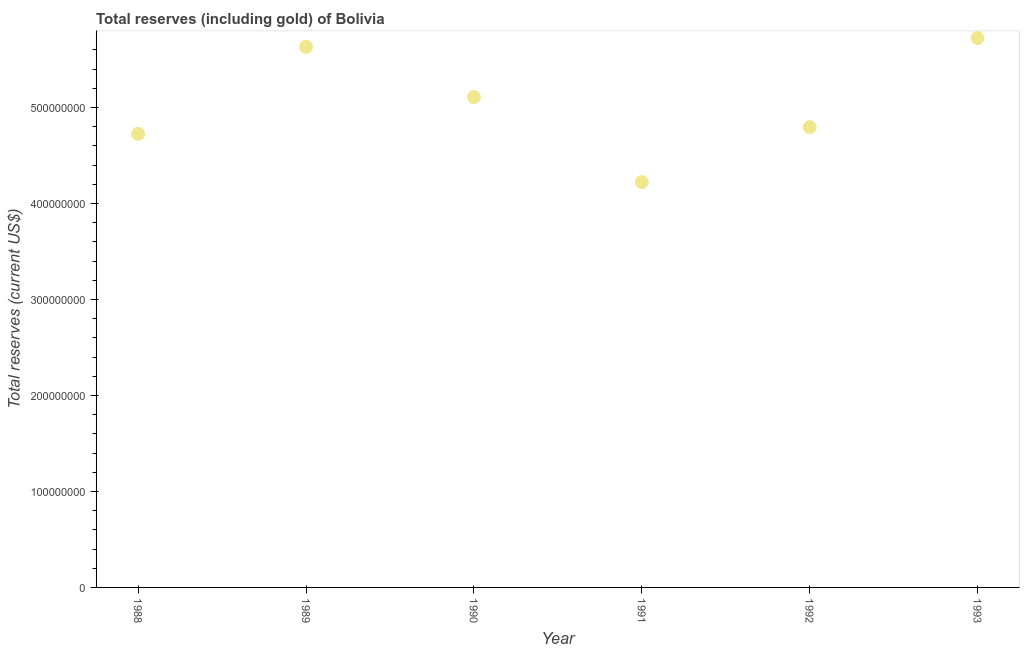What is the total reserves (including gold) in 1988?
Make the answer very short. 4.73e+08. Across all years, what is the maximum total reserves (including gold)?
Provide a succinct answer. 5.72e+08. Across all years, what is the minimum total reserves (including gold)?
Give a very brief answer. 4.22e+08. In which year was the total reserves (including gold) maximum?
Your answer should be compact. 1993. In which year was the total reserves (including gold) minimum?
Ensure brevity in your answer.  1991. What is the sum of the total reserves (including gold)?
Offer a very short reply. 3.02e+09. What is the difference between the total reserves (including gold) in 1990 and 1992?
Offer a terse response. 3.14e+07. What is the average total reserves (including gold) per year?
Give a very brief answer. 5.04e+08. What is the median total reserves (including gold)?
Provide a short and direct response. 4.95e+08. What is the ratio of the total reserves (including gold) in 1989 to that in 1991?
Your answer should be very brief. 1.33. What is the difference between the highest and the second highest total reserves (including gold)?
Your answer should be compact. 9.09e+06. What is the difference between the highest and the lowest total reserves (including gold)?
Your response must be concise. 1.50e+08. In how many years, is the total reserves (including gold) greater than the average total reserves (including gold) taken over all years?
Offer a very short reply. 3. Does the total reserves (including gold) monotonically increase over the years?
Offer a very short reply. No. How many years are there in the graph?
Offer a very short reply. 6. Are the values on the major ticks of Y-axis written in scientific E-notation?
Offer a very short reply. No. Does the graph contain any zero values?
Ensure brevity in your answer.  No. What is the title of the graph?
Give a very brief answer. Total reserves (including gold) of Bolivia. What is the label or title of the X-axis?
Make the answer very short. Year. What is the label or title of the Y-axis?
Your answer should be very brief. Total reserves (current US$). What is the Total reserves (current US$) in 1988?
Offer a very short reply. 4.73e+08. What is the Total reserves (current US$) in 1989?
Your answer should be very brief. 5.63e+08. What is the Total reserves (current US$) in 1990?
Your response must be concise. 5.11e+08. What is the Total reserves (current US$) in 1991?
Offer a very short reply. 4.22e+08. What is the Total reserves (current US$) in 1992?
Provide a succinct answer. 4.80e+08. What is the Total reserves (current US$) in 1993?
Your response must be concise. 5.72e+08. What is the difference between the Total reserves (current US$) in 1988 and 1989?
Ensure brevity in your answer.  -9.08e+07. What is the difference between the Total reserves (current US$) in 1988 and 1990?
Your answer should be very brief. -3.84e+07. What is the difference between the Total reserves (current US$) in 1988 and 1991?
Give a very brief answer. 5.02e+07. What is the difference between the Total reserves (current US$) in 1988 and 1992?
Provide a succinct answer. -6.99e+06. What is the difference between the Total reserves (current US$) in 1988 and 1993?
Give a very brief answer. -9.99e+07. What is the difference between the Total reserves (current US$) in 1989 and 1990?
Offer a terse response. 5.24e+07. What is the difference between the Total reserves (current US$) in 1989 and 1991?
Give a very brief answer. 1.41e+08. What is the difference between the Total reserves (current US$) in 1989 and 1992?
Make the answer very short. 8.38e+07. What is the difference between the Total reserves (current US$) in 1989 and 1993?
Ensure brevity in your answer.  -9.09e+06. What is the difference between the Total reserves (current US$) in 1990 and 1991?
Your answer should be compact. 8.86e+07. What is the difference between the Total reserves (current US$) in 1990 and 1992?
Keep it short and to the point. 3.14e+07. What is the difference between the Total reserves (current US$) in 1990 and 1993?
Provide a succinct answer. -6.15e+07. What is the difference between the Total reserves (current US$) in 1991 and 1992?
Give a very brief answer. -5.72e+07. What is the difference between the Total reserves (current US$) in 1991 and 1993?
Give a very brief answer. -1.50e+08. What is the difference between the Total reserves (current US$) in 1992 and 1993?
Provide a short and direct response. -9.29e+07. What is the ratio of the Total reserves (current US$) in 1988 to that in 1989?
Your answer should be compact. 0.84. What is the ratio of the Total reserves (current US$) in 1988 to that in 1990?
Your answer should be compact. 0.93. What is the ratio of the Total reserves (current US$) in 1988 to that in 1991?
Ensure brevity in your answer.  1.12. What is the ratio of the Total reserves (current US$) in 1988 to that in 1993?
Keep it short and to the point. 0.83. What is the ratio of the Total reserves (current US$) in 1989 to that in 1990?
Provide a succinct answer. 1.1. What is the ratio of the Total reserves (current US$) in 1989 to that in 1991?
Provide a short and direct response. 1.33. What is the ratio of the Total reserves (current US$) in 1989 to that in 1992?
Offer a very short reply. 1.18. What is the ratio of the Total reserves (current US$) in 1990 to that in 1991?
Provide a short and direct response. 1.21. What is the ratio of the Total reserves (current US$) in 1990 to that in 1992?
Your answer should be very brief. 1.06. What is the ratio of the Total reserves (current US$) in 1990 to that in 1993?
Your response must be concise. 0.89. What is the ratio of the Total reserves (current US$) in 1991 to that in 1992?
Keep it short and to the point. 0.88. What is the ratio of the Total reserves (current US$) in 1991 to that in 1993?
Your answer should be very brief. 0.74. What is the ratio of the Total reserves (current US$) in 1992 to that in 1993?
Keep it short and to the point. 0.84. 